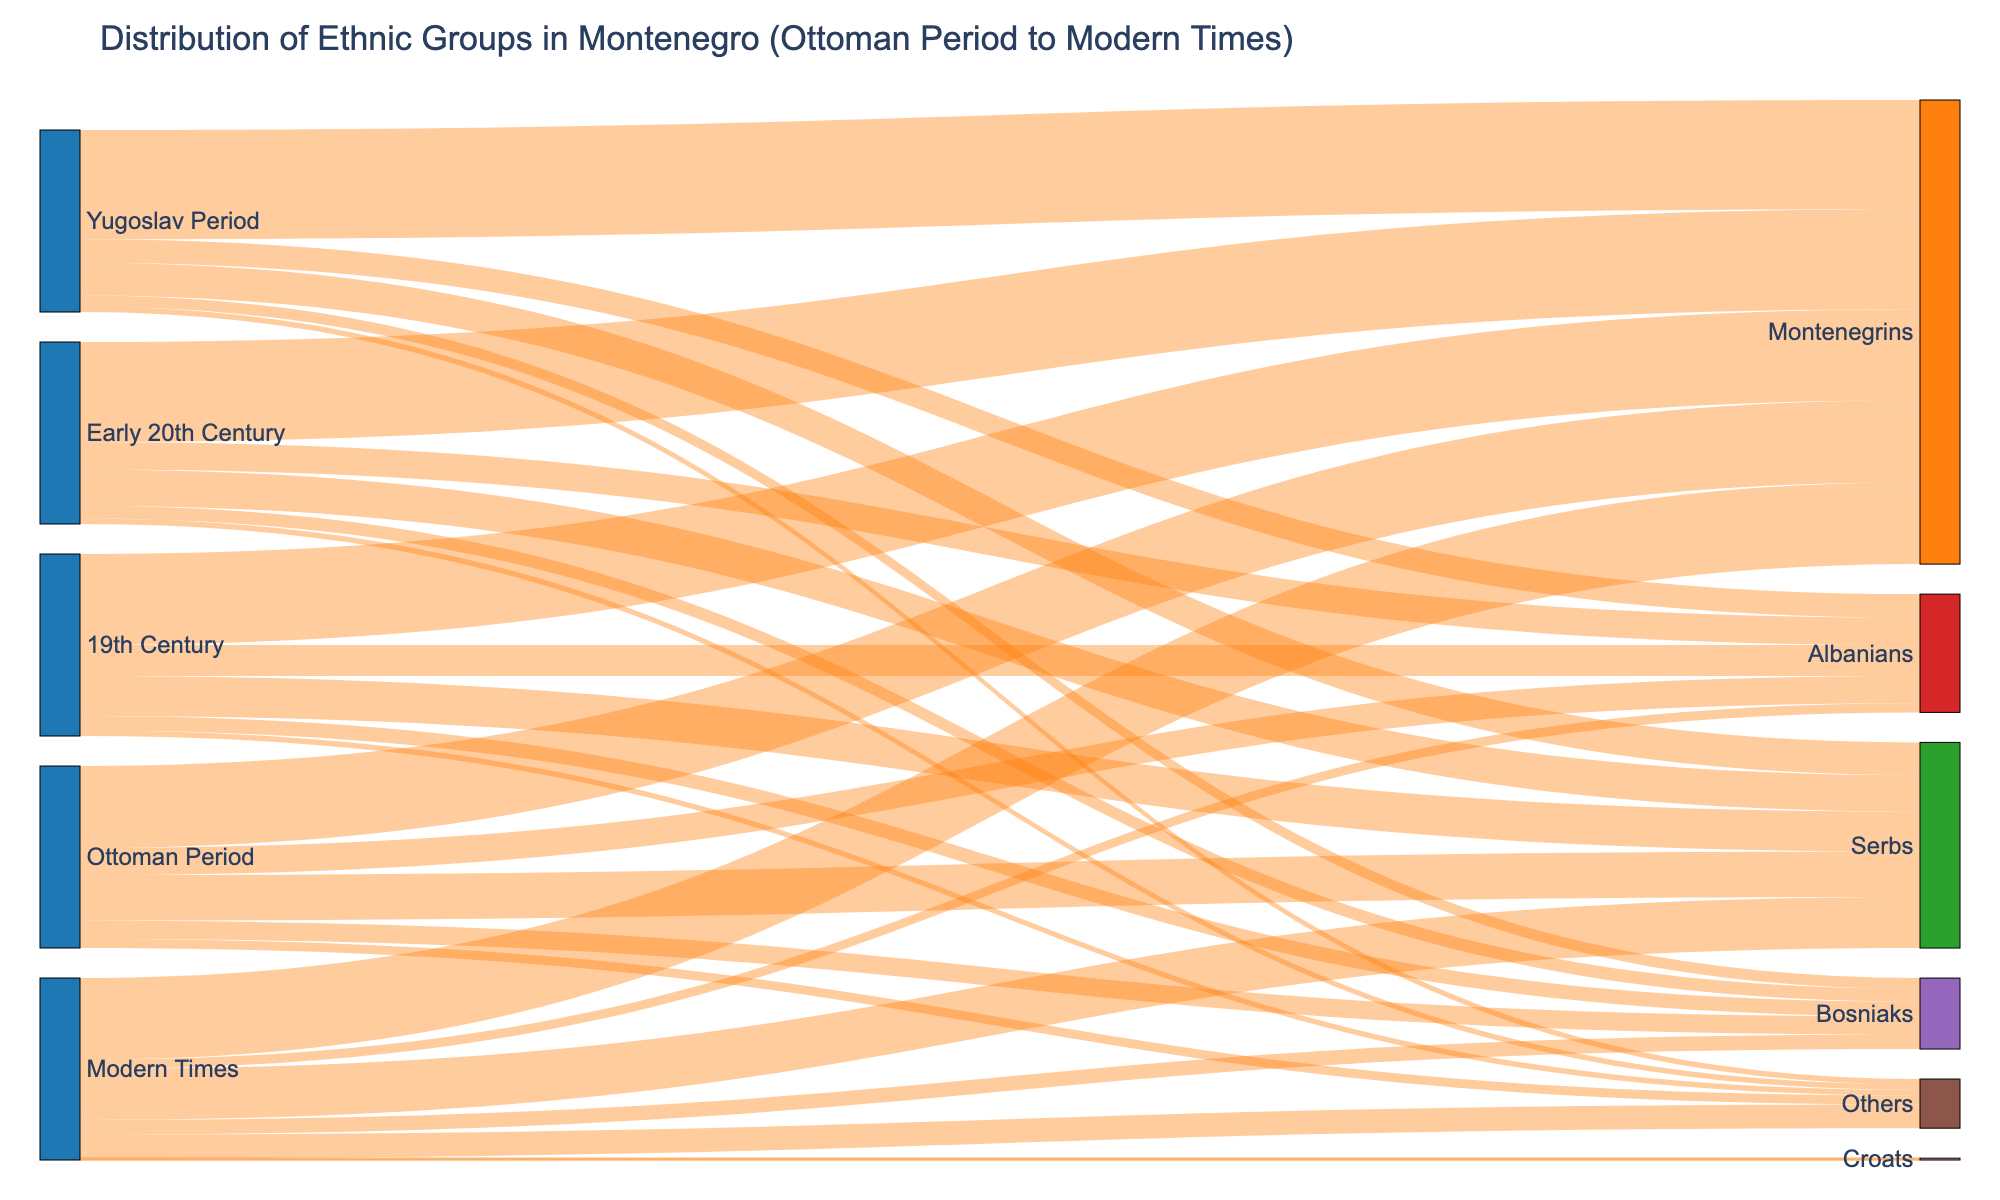What is the title of the Sankey diagram? The title is always positioned above the figure. By reading the text at the top, one can easily identify the title.
Answer: Distribution of Ethnic Groups in Montenegro (Ottoman Period to Modern Times) How many periods are represented in the diagram? Count the unique periods listed in the diagram. Each period serves as a source node for the ethnic groups.
Answer: 5 Which ethnic group had the largest population during the Yugoslav Period? Identify the Yugoslav Period source and trace the link with the highest value to its corresponding target ethnic group.
Answer: Montenegrins What is the total number of ethnic groups mentioned in the diagram? Count the unique target ethnic groups listed across all periods.
Answer: 7 Which period had the highest number of ethnic Montenegrins? Compare the values of Montenegrins for all periods and identify the period with the highest value.
Answer: Yugoslav Period How did the population of Serbs change from the Ottoman Period to Modern Times? Compare the value for Serbs during the Ottoman Period with that during Modern Times. Note any increase or decrease.
Answer: Increased Which ethnic group saw the largest decrease in population from the Yugoslav Period to Modern Times? Compare the values of each ethnic group during the Yugoslav Period and Modern Times, and identify the group with the largest decrease.
Answer: Albanians What is the total population represented in the Early 20th Century? Sum the values of all ethnic groups during the Early 20th Century period.
Answer: 100 What is the combined population of Bosniaks in both the 19th Century and Early 20th Century? Add the population values of Bosniaks from both the 19th Century and the Early 20th Century.
Answer: 15 Which period had the smallest population of 'Others'? Compare the population values of 'Others' across all periods and identify the smallest one.
Answer: 19th Century 